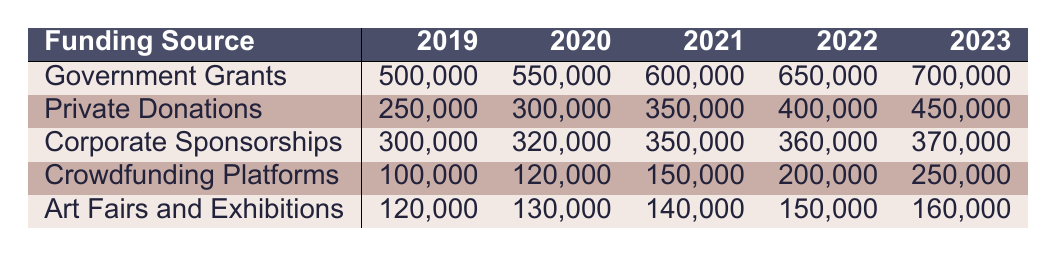What was the highest funding source in 2021? By examining the values in the table for 2021, Government Grants show the highest amount of 600,000 compared to Private Donations with 350,000, Corporate Sponsorships with 350,000, Crowdfunding Platforms with 150,000, and Art Fairs and Exhibitions with 140,000.
Answer: Government Grants How much funding did Crowdfunding Platforms receive in 2023? The table shows that Crowdfunding Platforms received 250,000 in 2023.
Answer: 250,000 What is the total funding from Private Donations over the five years? Adding the amounts from each year for Private Donations: 250,000 + 300,000 + 350,000 + 400,000 + 450,000 = 1,750,000 gives the total amount over the five years.
Answer: 1,750,000 Did Corporate Sponsorships increase every year from 2019 to 2023? Checking the yearly amounts, we see Corporate Sponsorships: 300,000, 320,000, 350,000, 360,000, 370,000 show consistent increases each year without any decreases.
Answer: Yes What is the average funding from Art Fairs and Exhibitions over the five years? To find the average, sum the yearly values: 120,000 + 130,000 + 140,000 + 150,000 + 160,000 = 700,000. Then divide this total by 5 (years), which results in an average of 140,000.
Answer: 140,000 Which funding source had the lowest total funding in 2019? By looking at 2019: Government Grants (500,000), Private Donations (250,000), Corporate Sponsorships (300,000), Crowdfunding Platforms (100,000), and Art Fairs and Exhibitions (120,000), Crowdfunding Platforms has the lowest.
Answer: Crowdfunding Platforms What was the change in funding for Government Grants from 2019 to 2023? The funding for Government Grants in 2019 is 500,000 and in 2023 it is 700,000. The change is calculated as 700,000 - 500,000 = 200,000, indicating an increase.
Answer: 200,000 How much more funding did Private Donations receive compared to Corporate Sponsorships in 2022? In 2022, Private Donations were 400,000 and Corporate Sponsorships were 360,000. The difference is 400,000 - 360,000 = 40,000, showing that Private Donations received more.
Answer: 40,000 What was the percentage increase in funding for Crowdfunding Platforms from 2019 to 2022? The funding increased from 100,000 in 2019 to 200,000 in 2022, which is a difference of 200,000 - 100,000 = 100,000. To find the percentage increase: (100,000 / 100,000) * 100 = 100%.
Answer: 100% 